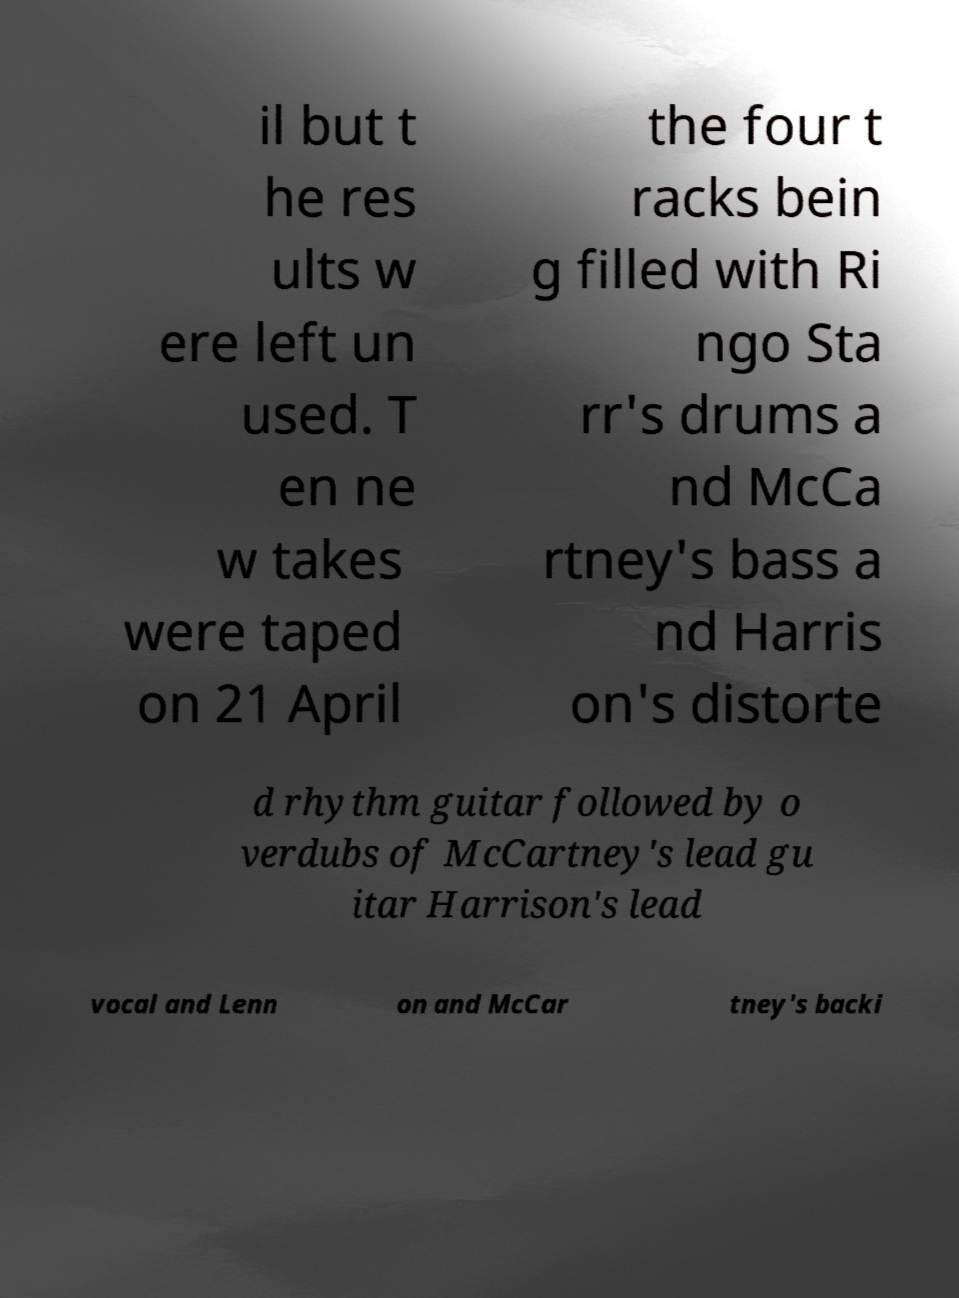Can you accurately transcribe the text from the provided image for me? il but t he res ults w ere left un used. T en ne w takes were taped on 21 April the four t racks bein g filled with Ri ngo Sta rr's drums a nd McCa rtney's bass a nd Harris on's distorte d rhythm guitar followed by o verdubs of McCartney's lead gu itar Harrison's lead vocal and Lenn on and McCar tney's backi 